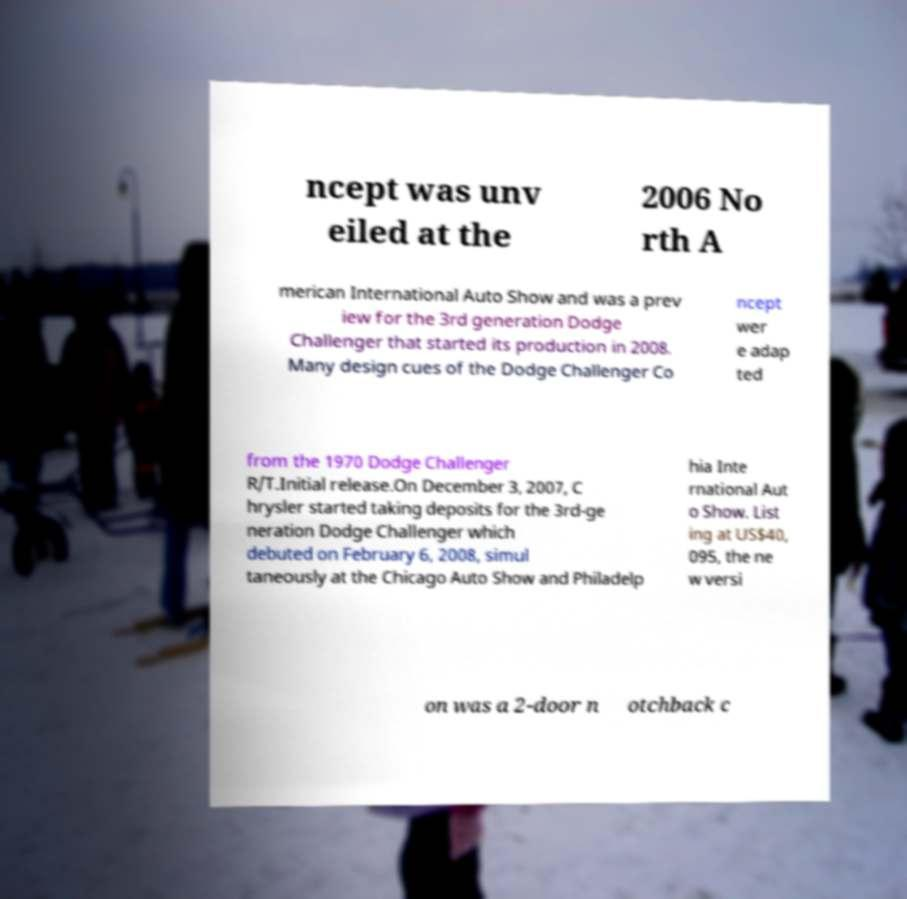There's text embedded in this image that I need extracted. Can you transcribe it verbatim? ncept was unv eiled at the 2006 No rth A merican International Auto Show and was a prev iew for the 3rd generation Dodge Challenger that started its production in 2008. Many design cues of the Dodge Challenger Co ncept wer e adap ted from the 1970 Dodge Challenger R/T.Initial release.On December 3, 2007, C hrysler started taking deposits for the 3rd-ge neration Dodge Challenger which debuted on February 6, 2008, simul taneously at the Chicago Auto Show and Philadelp hia Inte rnational Aut o Show. List ing at US$40, 095, the ne w versi on was a 2-door n otchback c 